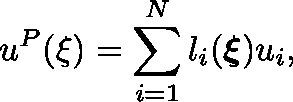Convert formula to latex. <formula><loc_0><loc_0><loc_500><loc_500>u ^ { P } ( \xi ) = \sum _ { i = 1 } ^ { N } l _ { i } ( \xi ) u _ { i } ,</formula> 